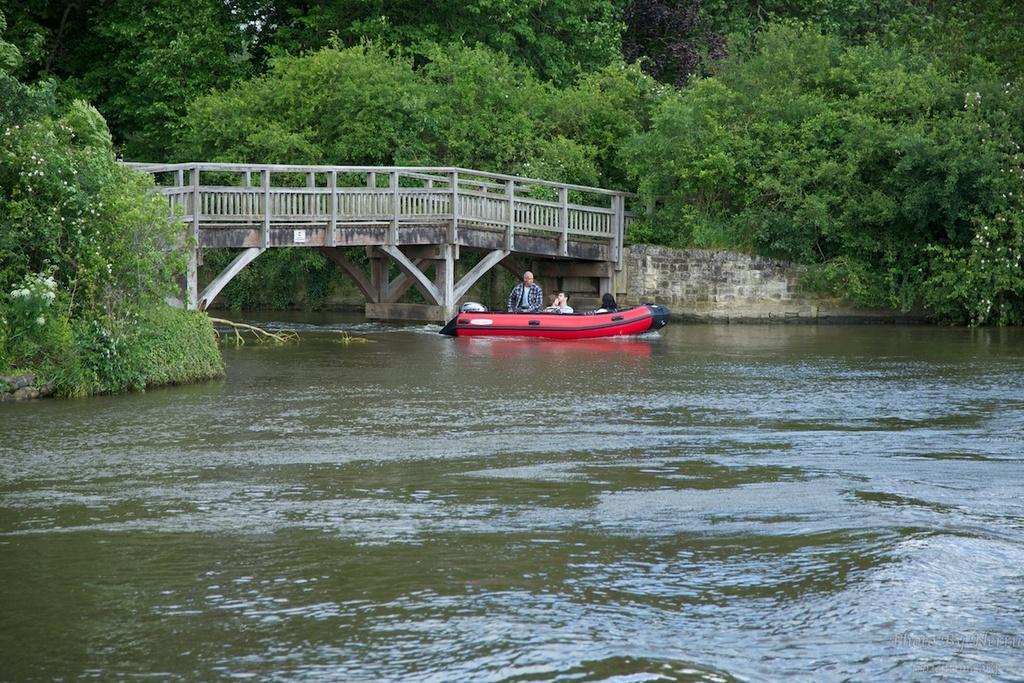How would you summarize this image in a sentence or two? In this image we can see few persons are in on the boat on the water and we can see bridge, wall and railings. In the background there are trees and plants with flowers. 